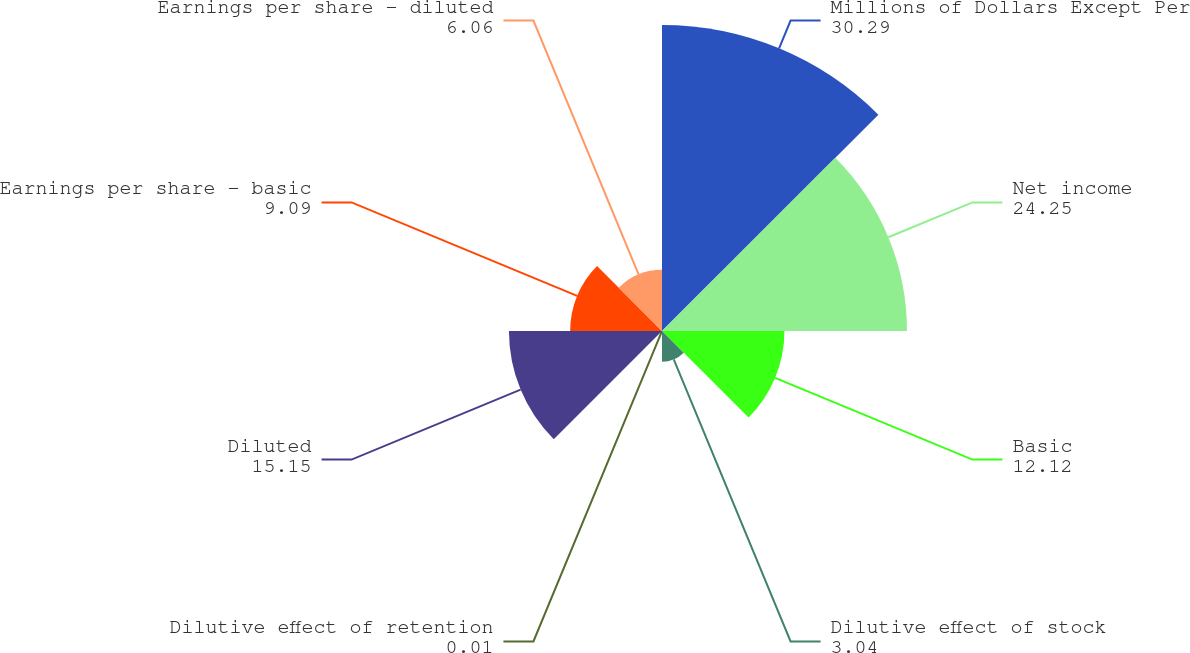<chart> <loc_0><loc_0><loc_500><loc_500><pie_chart><fcel>Millions of Dollars Except Per<fcel>Net income<fcel>Basic<fcel>Dilutive effect of stock<fcel>Dilutive effect of retention<fcel>Diluted<fcel>Earnings per share - basic<fcel>Earnings per share - diluted<nl><fcel>30.29%<fcel>24.25%<fcel>12.12%<fcel>3.04%<fcel>0.01%<fcel>15.15%<fcel>9.09%<fcel>6.06%<nl></chart> 